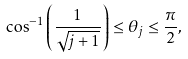Convert formula to latex. <formula><loc_0><loc_0><loc_500><loc_500>\cos ^ { - 1 } \left ( \frac { 1 } { \sqrt { j + 1 } } \right ) \leq \theta _ { j } \leq \frac { \pi } { 2 } ,</formula> 